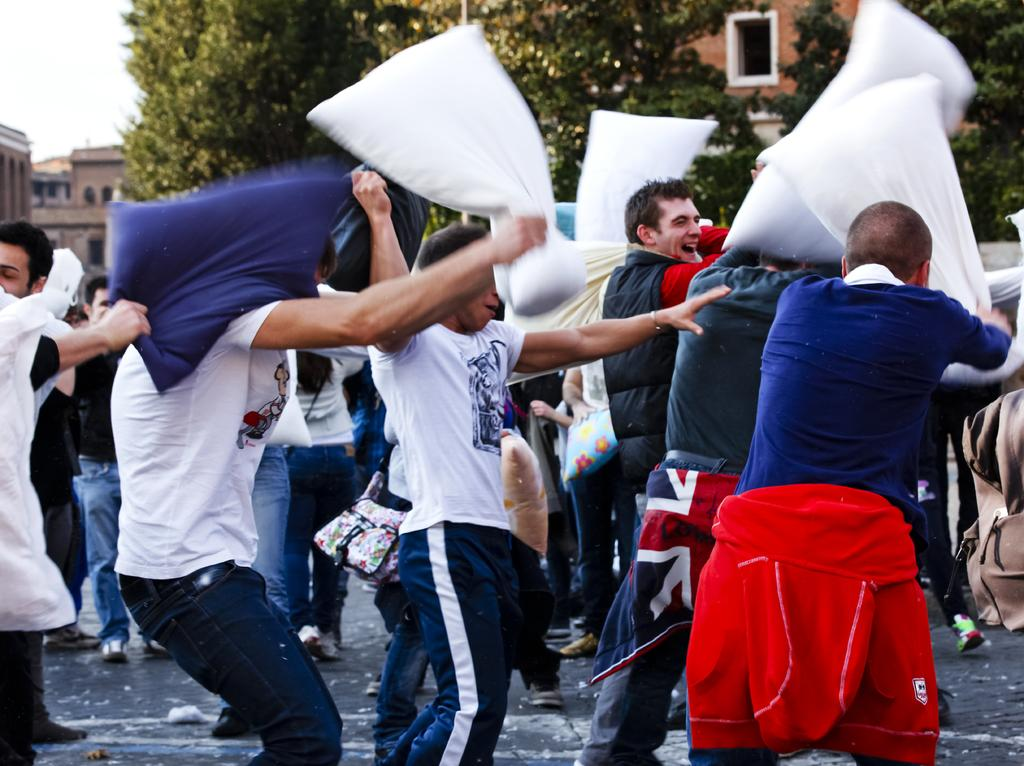How many people are in the image? There is a group of persons in the image. What are the persons doing in the image? The persons are standing and playing with pillows. What can be seen in the background of the image? There are trees and buildings in the background of the image. What type of sock is being used to express disgust in the image? There is no sock present in the image, nor is there any expression of disgust. 